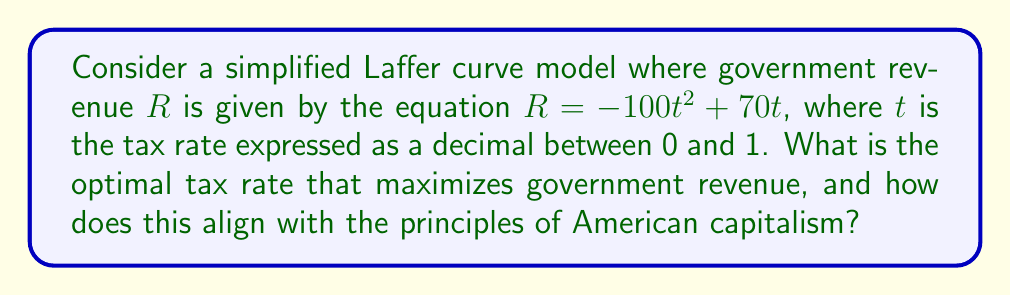Solve this math problem. To find the optimal tax rate that maximizes government revenue, we need to follow these steps:

1) The Laffer curve equation is given as:
   $$R = -100t^2 + 70t$$

2) To find the maximum point, we need to differentiate $R$ with respect to $t$ and set it equal to zero:
   $$\frac{dR}{dt} = -200t + 70 = 0$$

3) Solve for $t$:
   $$-200t + 70 = 0$$
   $$-200t = -70$$
   $$t = \frac{70}{200} = 0.35$$

4) To confirm this is a maximum, we can check the second derivative:
   $$\frac{d^2R}{dt^2} = -200$$
   Since this is negative, we confirm that $t = 0.35$ gives a maximum.

5) Therefore, the optimal tax rate is 35%.

This result aligns with the principles of American capitalism in several ways:
- It demonstrates the balance between government revenue and economic growth.
- It shows that excessive taxation (beyond 35%) could lead to decreased revenue, supporting the argument for lower taxes.
- It illustrates the concept of incentives in a free market system, where overly high tax rates may discourage economic activity.
Answer: 35% 